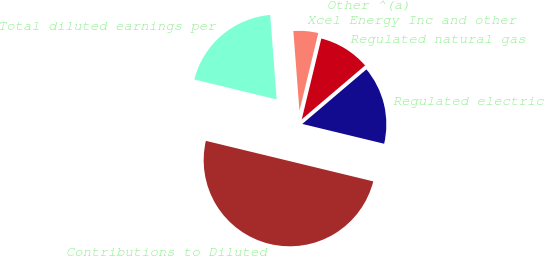<chart> <loc_0><loc_0><loc_500><loc_500><pie_chart><fcel>Contributions to Diluted<fcel>Regulated electric<fcel>Regulated natural gas<fcel>Other ^(a)<fcel>Xcel Energy Inc and other<fcel>Total diluted earnings per<nl><fcel>50.0%<fcel>15.0%<fcel>10.0%<fcel>0.0%<fcel>5.0%<fcel>20.0%<nl></chart> 